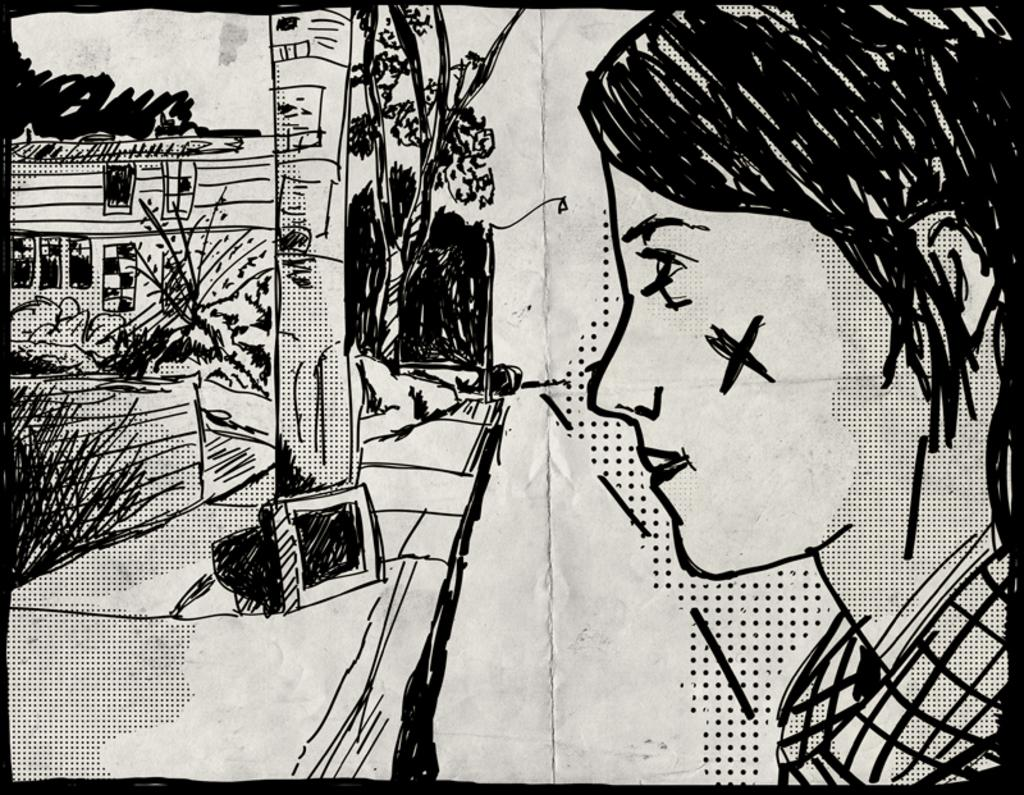What is depicted in the image as the main subject? There is a drawing of a person in the image. What other elements are present in the image besides the drawing? There are plants and a house in the image. What type of vegetation can be seen in the image? There are trees in the image. How many deer are visible in the image? There are no deer present in the image. Is there an owl perched on the house in the image? There is no owl present in the image. 